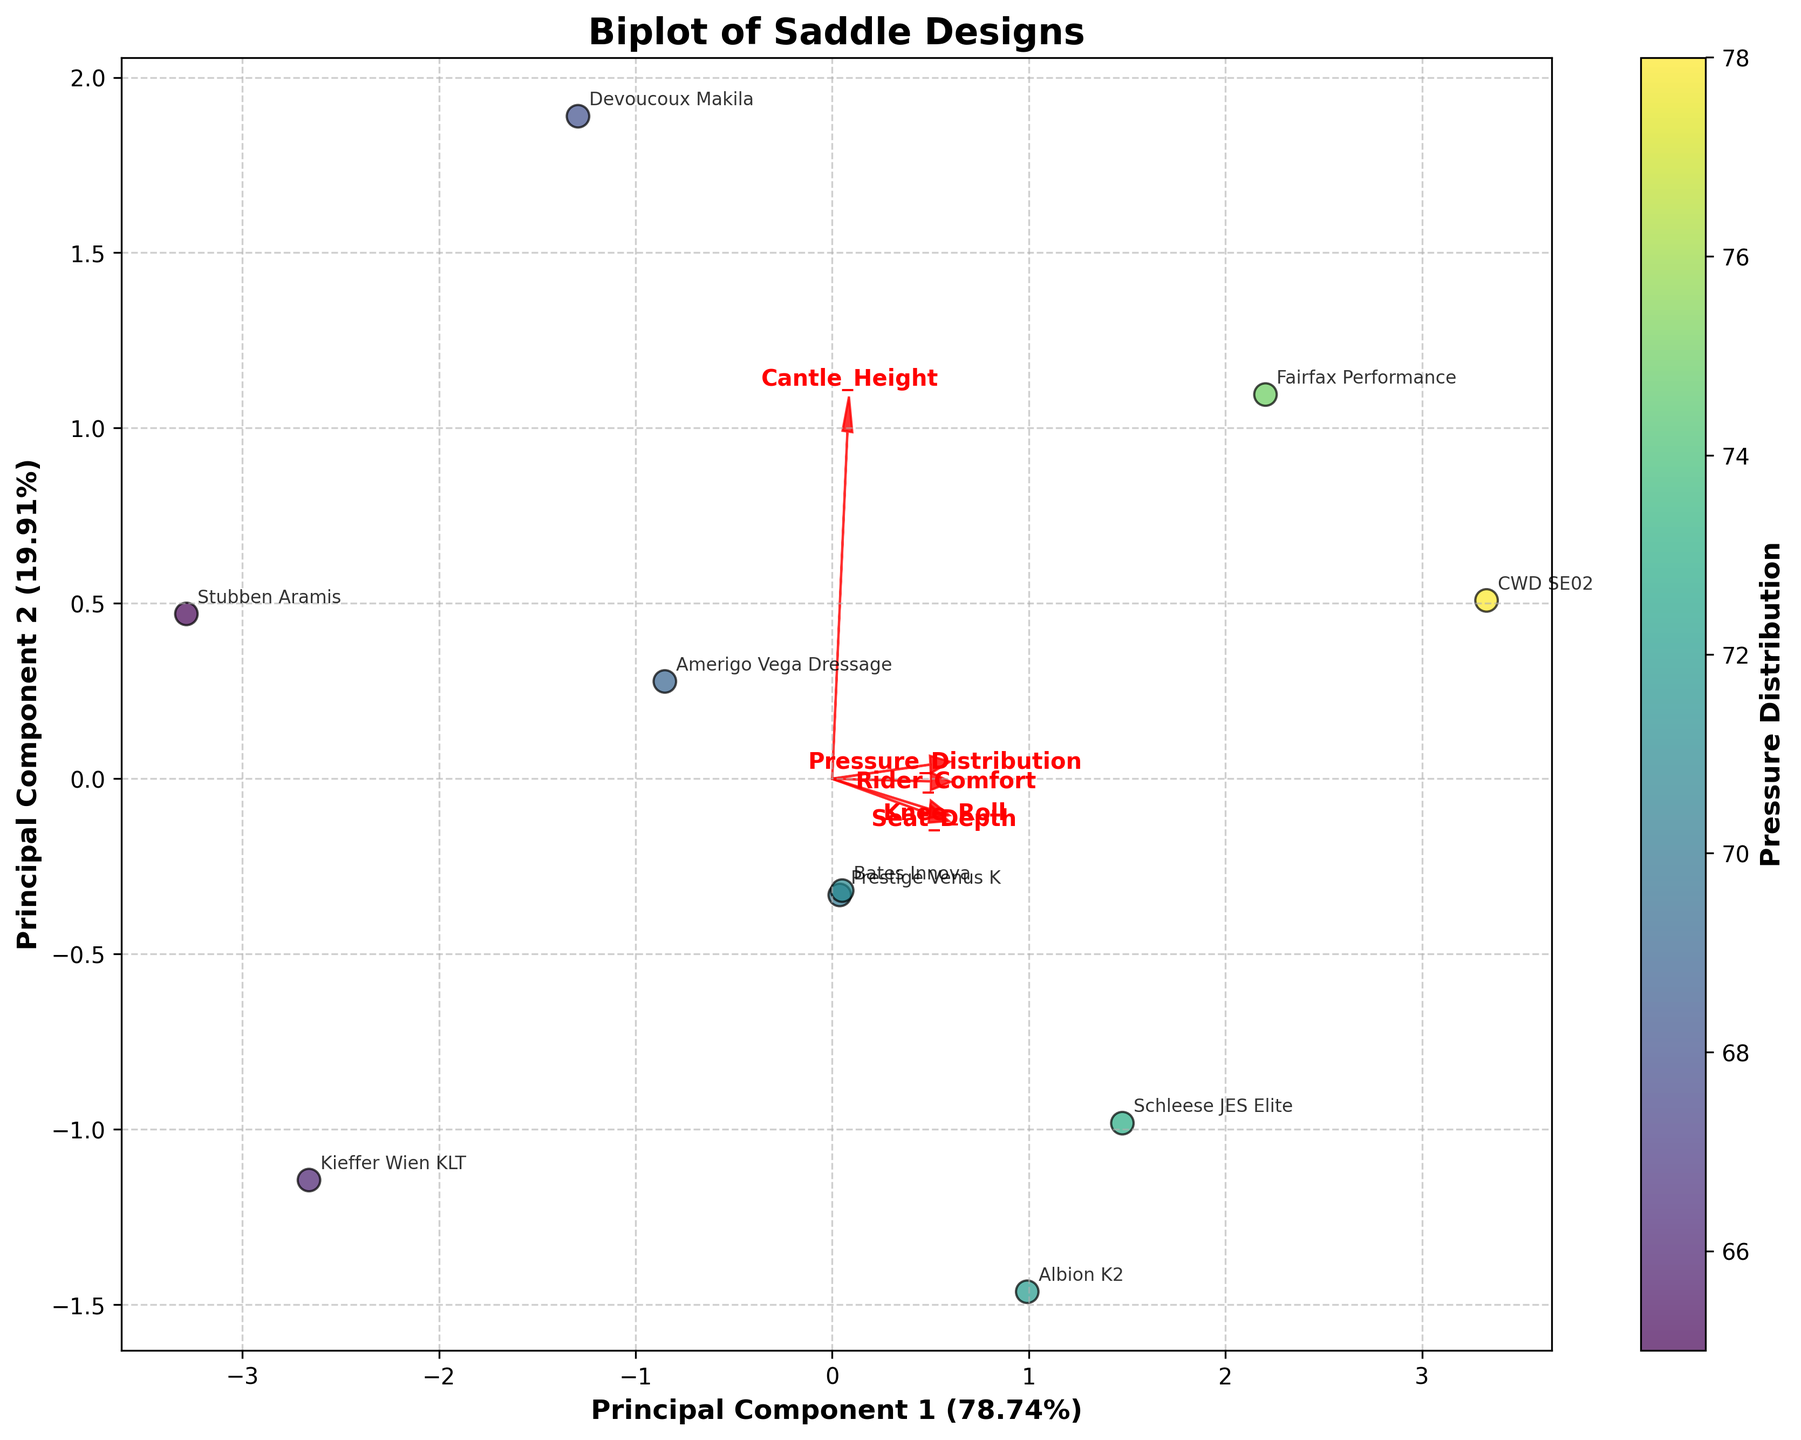What does the color of the data points represent? The color of the data points is mapped to the 'Pressure Distribution'. This is evident from the colorbar next to the scatter plot that labels the 'Pressure Distribution'.
Answer: Pressure Distribution What are the axis labels in the biplot? The x-axis is labeled 'Principal Component 1' and the y-axis is labeled 'Principal Component 2', each followed by the percentage of variance they explain.
Answer: Principal Component 1 and Principal Component 2 Which saddle design has the highest pressure distribution? By looking at the color mapping, the point with the darkest color within the 'viridis' color map has the highest pressure distribution, which corresponds to the 'CWD SE02'.
Answer: CWD SE02 How many saddle designs are compared in the figure? Each data point represents a saddle design, and each is annotated. By counting these annotations, we find ten different saddle designs represented.
Answer: 10 Which two features are plotted as vectors in the same direction? Examine the directions of the arrows representing the features. 'Seat_Depth' and 'Knee_Roll' vectors point in nearly the same direction.
Answer: Seat_Depth and Knee_Roll Which principal component explains more variance in the data? By comparing the percentage labels on both the x-axis and y-axis, 'Principal Component 1' explains more variance than 'Principal Component 2'.
Answer: Principal Component 1 Which features are negatively correlated based on the direction of their vectors? Features with vectors pointing in opposite directions are negatively correlated. 'Pressure_Distribution' and 'Seat_Depth' point in almost opposite directions.
Answer: Pressure_Distribution and Seat_Depth How does the 'Rider_Comfort' vector align relative to 'Principal Component 1'? The 'Rider_Comfort' vector points upwards, indicating a positive alignment with 'Principal Component 2' rather than 'Principal Component 1'.
Answer: Positive alignment with Principal Component 2 Which saddle design lies closest to the origin? By inspecting the scatter plot, 'Stubben Aramis' lies closest to the origin (0,0) of the coordinate plane.
Answer: Stubben Aramis What is the purpose of the arrows in the biplot? The arrows represent the loadings of the original features on the principal components. They indicate the direction and magnitude of each feature's contribution to the PCA components.
Answer: Represent feature loadings 